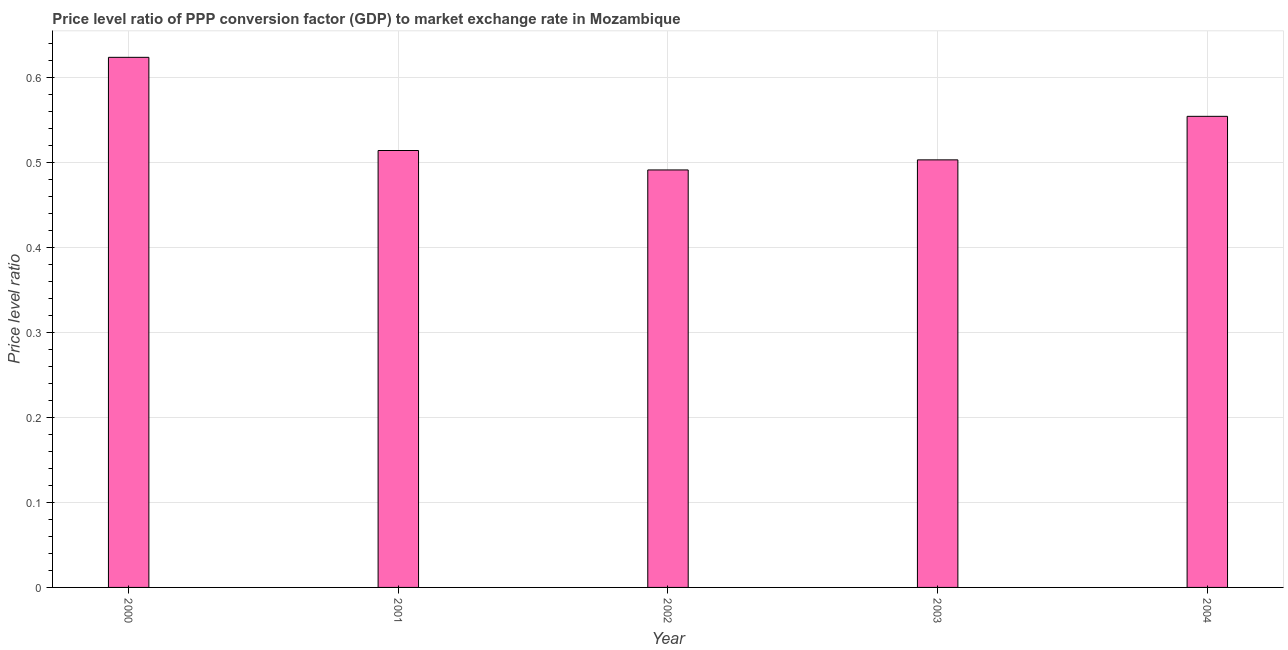Does the graph contain any zero values?
Your answer should be compact. No. Does the graph contain grids?
Your answer should be compact. Yes. What is the title of the graph?
Your answer should be compact. Price level ratio of PPP conversion factor (GDP) to market exchange rate in Mozambique. What is the label or title of the Y-axis?
Give a very brief answer. Price level ratio. What is the price level ratio in 2004?
Provide a short and direct response. 0.55. Across all years, what is the maximum price level ratio?
Your answer should be compact. 0.62. Across all years, what is the minimum price level ratio?
Give a very brief answer. 0.49. In which year was the price level ratio minimum?
Make the answer very short. 2002. What is the sum of the price level ratio?
Give a very brief answer. 2.69. What is the difference between the price level ratio in 2000 and 2003?
Your answer should be very brief. 0.12. What is the average price level ratio per year?
Provide a succinct answer. 0.54. What is the median price level ratio?
Give a very brief answer. 0.51. In how many years, is the price level ratio greater than 0.12 ?
Ensure brevity in your answer.  5. What is the ratio of the price level ratio in 2000 to that in 2003?
Provide a short and direct response. 1.24. What is the difference between the highest and the second highest price level ratio?
Make the answer very short. 0.07. What is the difference between the highest and the lowest price level ratio?
Your response must be concise. 0.13. In how many years, is the price level ratio greater than the average price level ratio taken over all years?
Offer a very short reply. 2. How many years are there in the graph?
Keep it short and to the point. 5. What is the Price level ratio of 2000?
Offer a very short reply. 0.62. What is the Price level ratio in 2001?
Provide a succinct answer. 0.51. What is the Price level ratio of 2002?
Give a very brief answer. 0.49. What is the Price level ratio in 2003?
Keep it short and to the point. 0.5. What is the Price level ratio in 2004?
Your answer should be very brief. 0.55. What is the difference between the Price level ratio in 2000 and 2001?
Offer a very short reply. 0.11. What is the difference between the Price level ratio in 2000 and 2002?
Offer a very short reply. 0.13. What is the difference between the Price level ratio in 2000 and 2003?
Offer a very short reply. 0.12. What is the difference between the Price level ratio in 2000 and 2004?
Your response must be concise. 0.07. What is the difference between the Price level ratio in 2001 and 2002?
Give a very brief answer. 0.02. What is the difference between the Price level ratio in 2001 and 2003?
Give a very brief answer. 0.01. What is the difference between the Price level ratio in 2001 and 2004?
Ensure brevity in your answer.  -0.04. What is the difference between the Price level ratio in 2002 and 2003?
Ensure brevity in your answer.  -0.01. What is the difference between the Price level ratio in 2002 and 2004?
Keep it short and to the point. -0.06. What is the difference between the Price level ratio in 2003 and 2004?
Provide a short and direct response. -0.05. What is the ratio of the Price level ratio in 2000 to that in 2001?
Ensure brevity in your answer.  1.21. What is the ratio of the Price level ratio in 2000 to that in 2002?
Make the answer very short. 1.27. What is the ratio of the Price level ratio in 2000 to that in 2003?
Your answer should be compact. 1.24. What is the ratio of the Price level ratio in 2001 to that in 2002?
Provide a succinct answer. 1.05. What is the ratio of the Price level ratio in 2001 to that in 2004?
Make the answer very short. 0.93. What is the ratio of the Price level ratio in 2002 to that in 2004?
Your answer should be very brief. 0.89. What is the ratio of the Price level ratio in 2003 to that in 2004?
Give a very brief answer. 0.91. 